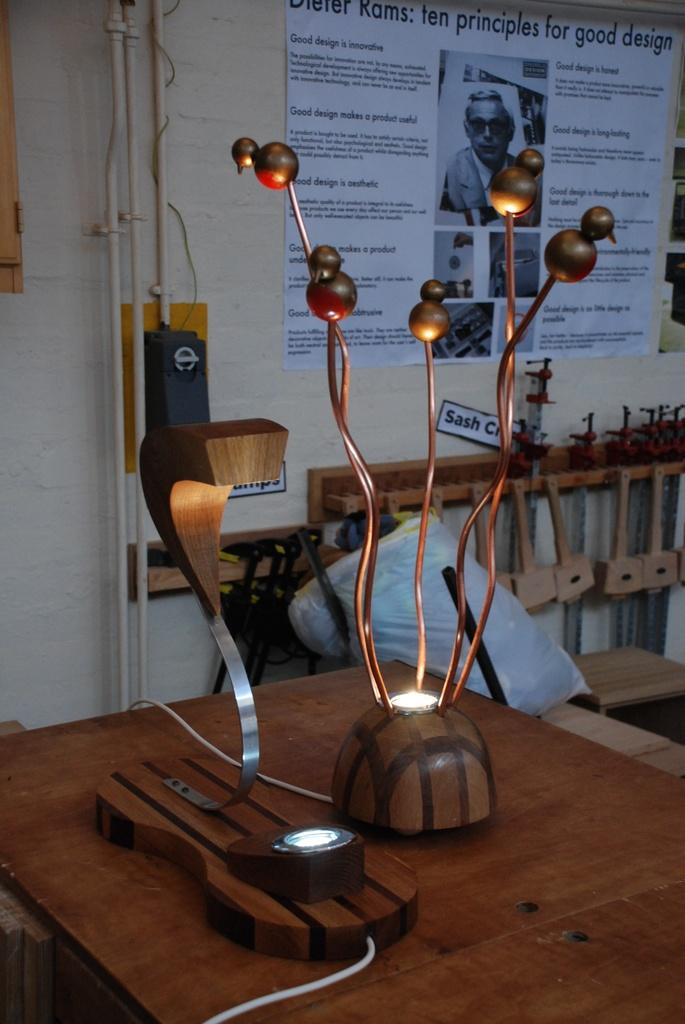What are the two objects on the table in the image? The information provided does not specify the objects on the table. What type of cover is present in the image? There is a plastic cover in the image. What can be seen on the wall in the image? There are posters on the wall. What type of structure is visible in the image? There are pipes visible in the image. Can you describe any other objects present in the image? There are additional objects present in the image, but their specific details are not provided. What type of thread is being used to create the invention in the image? There is no mention of an invention or thread in the image; the provided facts only mention objects on a table, a plastic cover, posters on the wall, pipes, and additional objects. 